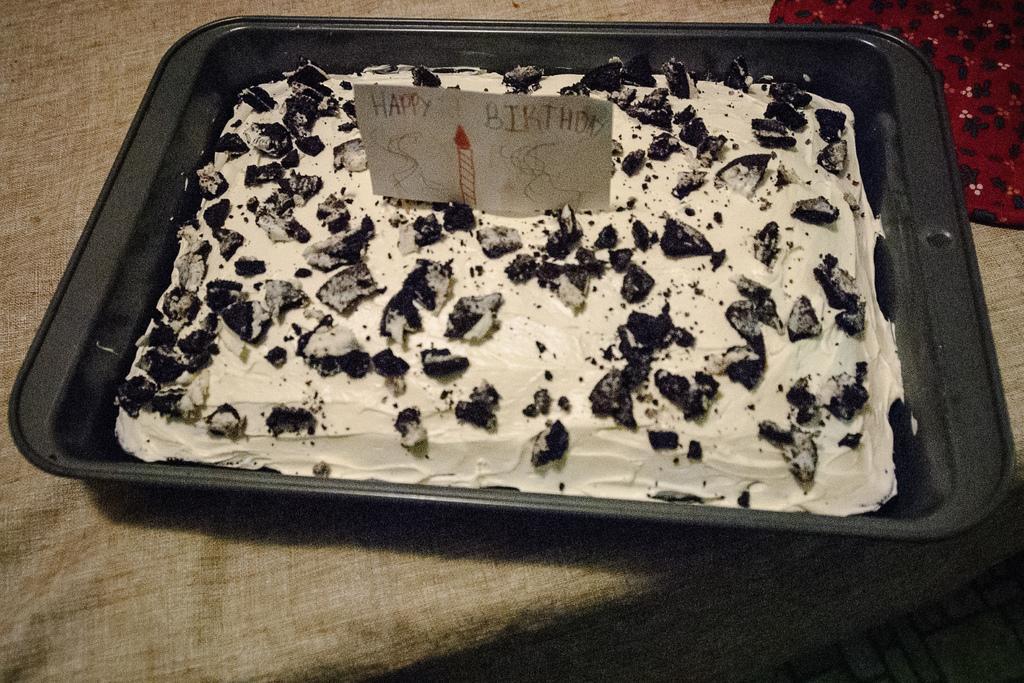Please provide a concise description of this image. In this image black color tray might be kept on table, on top tray there is a cake on which pieces of chocolates, in the top right there is a cloth might be kept on table. 